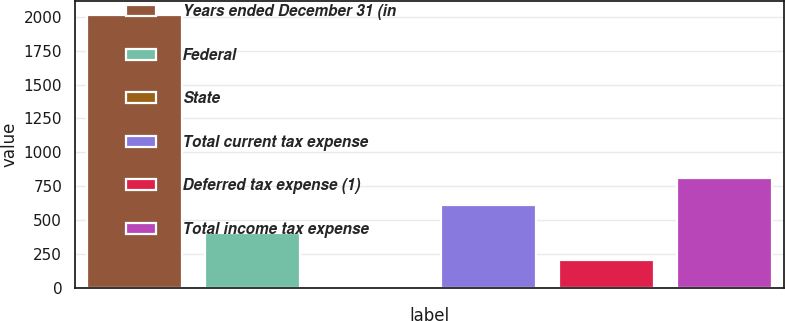Convert chart to OTSL. <chart><loc_0><loc_0><loc_500><loc_500><bar_chart><fcel>Years ended December 31 (in<fcel>Federal<fcel>State<fcel>Total current tax expense<fcel>Deferred tax expense (1)<fcel>Total income tax expense<nl><fcel>2012<fcel>408.08<fcel>7.1<fcel>608.57<fcel>207.59<fcel>809.06<nl></chart> 